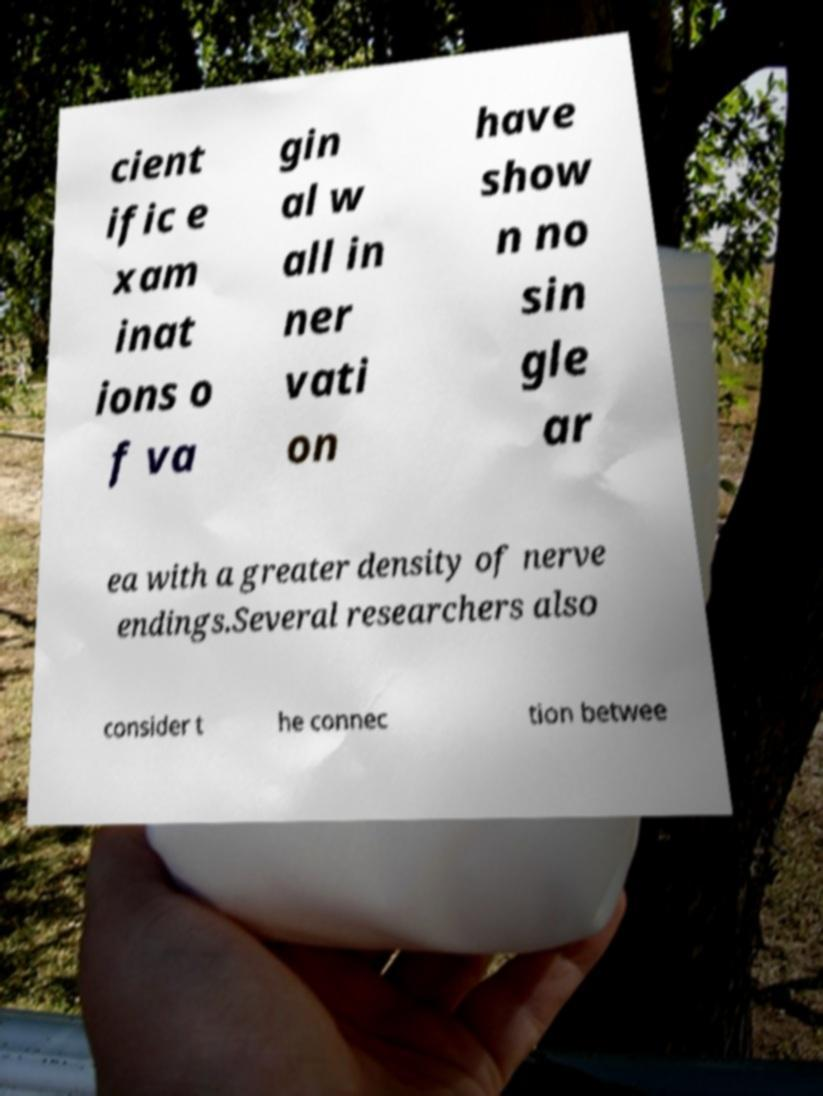For documentation purposes, I need the text within this image transcribed. Could you provide that? cient ific e xam inat ions o f va gin al w all in ner vati on have show n no sin gle ar ea with a greater density of nerve endings.Several researchers also consider t he connec tion betwee 